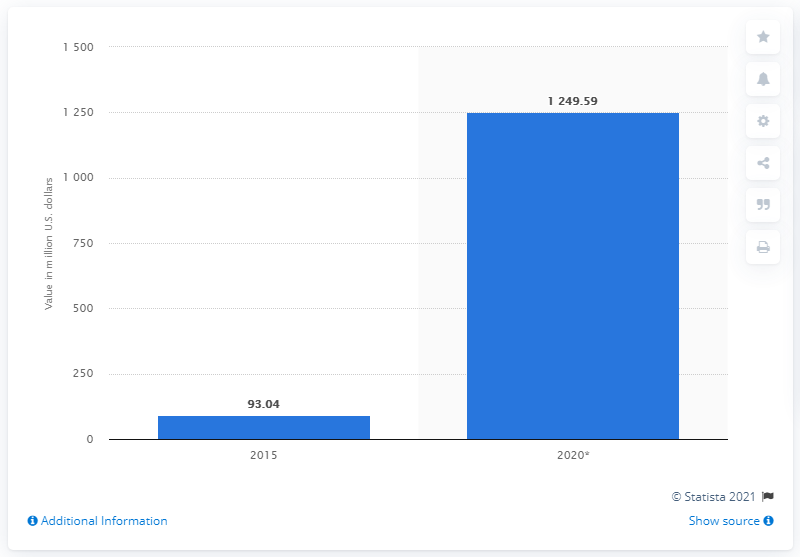Point out several critical features in this image. The education gamification market was valued at approximately 93.04 million US dollars in 2015. 